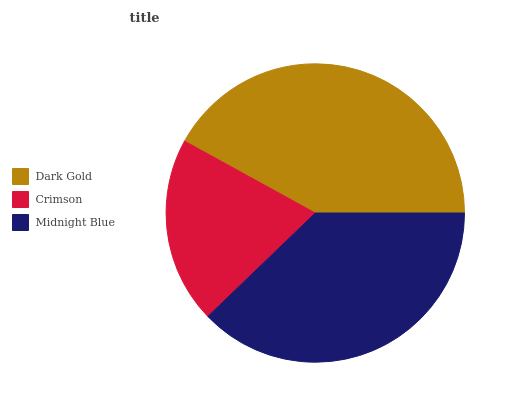Is Crimson the minimum?
Answer yes or no. Yes. Is Dark Gold the maximum?
Answer yes or no. Yes. Is Midnight Blue the minimum?
Answer yes or no. No. Is Midnight Blue the maximum?
Answer yes or no. No. Is Midnight Blue greater than Crimson?
Answer yes or no. Yes. Is Crimson less than Midnight Blue?
Answer yes or no. Yes. Is Crimson greater than Midnight Blue?
Answer yes or no. No. Is Midnight Blue less than Crimson?
Answer yes or no. No. Is Midnight Blue the high median?
Answer yes or no. Yes. Is Midnight Blue the low median?
Answer yes or no. Yes. Is Crimson the high median?
Answer yes or no. No. Is Crimson the low median?
Answer yes or no. No. 